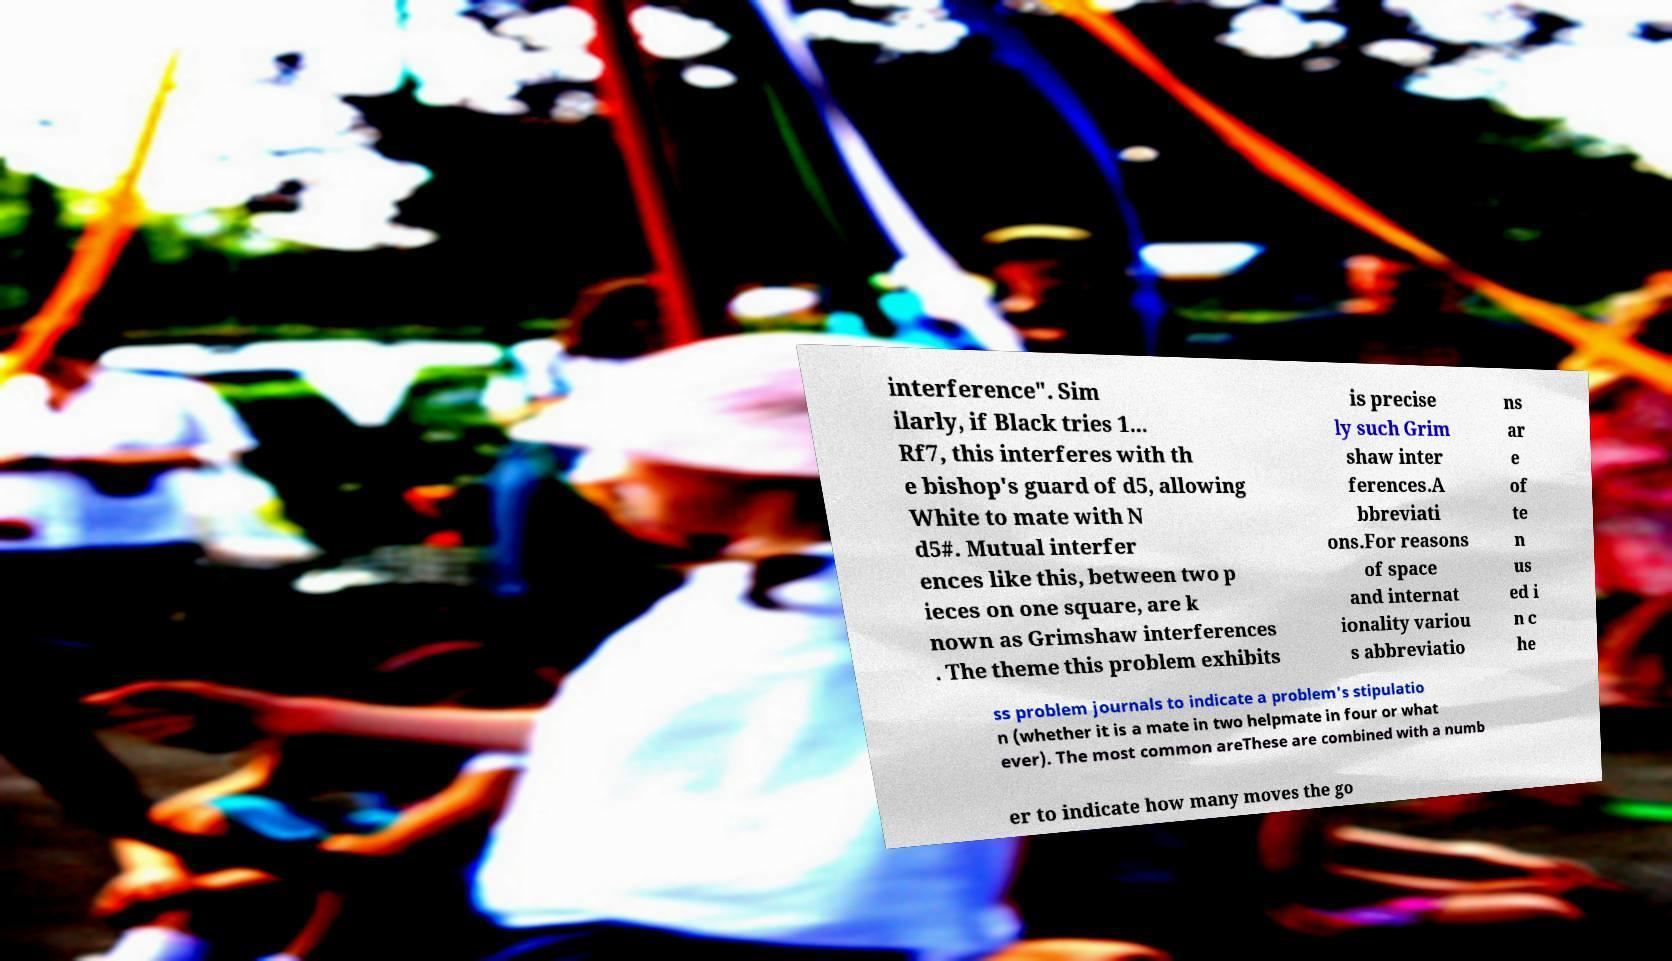Could you extract and type out the text from this image? interference". Sim ilarly, if Black tries 1... Rf7, this interferes with th e bishop's guard of d5, allowing White to mate with N d5#. Mutual interfer ences like this, between two p ieces on one square, are k nown as Grimshaw interferences . The theme this problem exhibits is precise ly such Grim shaw inter ferences.A bbreviati ons.For reasons of space and internat ionality variou s abbreviatio ns ar e of te n us ed i n c he ss problem journals to indicate a problem's stipulatio n (whether it is a mate in two helpmate in four or what ever). The most common areThese are combined with a numb er to indicate how many moves the go 